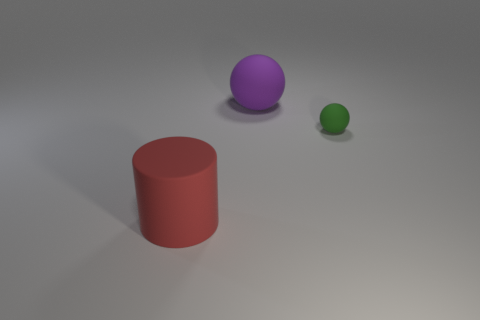How big is the sphere right of the large object that is to the right of the big rubber cylinder?
Offer a terse response. Small. Is the shape of the green rubber object the same as the big red thing?
Provide a short and direct response. No. How many metal objects are tiny things or tiny yellow cylinders?
Ensure brevity in your answer.  0. Are there any red rubber things that have the same size as the purple sphere?
Offer a terse response. Yes. How many matte spheres have the same size as the red matte cylinder?
Give a very brief answer. 1. Does the object that is behind the tiny green matte ball have the same size as the matte thing that is to the left of the big purple thing?
Ensure brevity in your answer.  Yes. What number of objects are large blue metallic cylinders or matte objects in front of the small ball?
Your response must be concise. 1. What color is the tiny matte thing?
Keep it short and to the point. Green. There is a thing in front of the object that is right of the large rubber thing that is behind the cylinder; what is it made of?
Your answer should be compact. Rubber. There is a green ball that is the same material as the large red object; what size is it?
Your response must be concise. Small. 